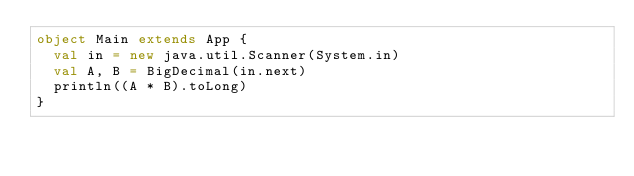Convert code to text. <code><loc_0><loc_0><loc_500><loc_500><_Scala_>object Main extends App {
  val in = new java.util.Scanner(System.in)
  val A, B = BigDecimal(in.next)
  println((A * B).toLong)
}</code> 